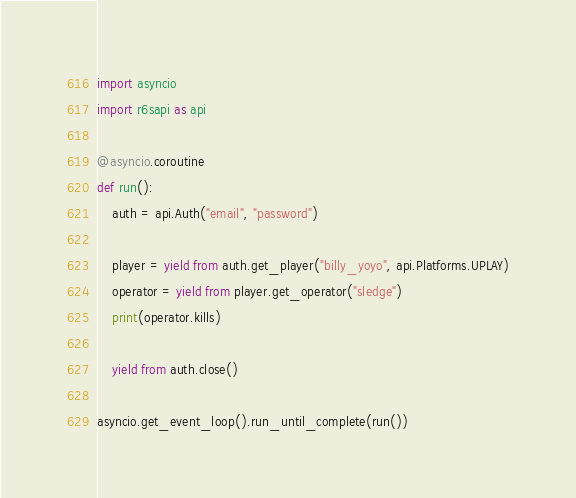<code> <loc_0><loc_0><loc_500><loc_500><_Python_>import asyncio
import r6sapi as api

@asyncio.coroutine
def run():
    auth = api.Auth("email", "password")
    
    player = yield from auth.get_player("billy_yoyo", api.Platforms.UPLAY)
    operator = yield from player.get_operator("sledge")
    print(operator.kills)

    yield from auth.close()
    
asyncio.get_event_loop().run_until_complete(run())</code> 